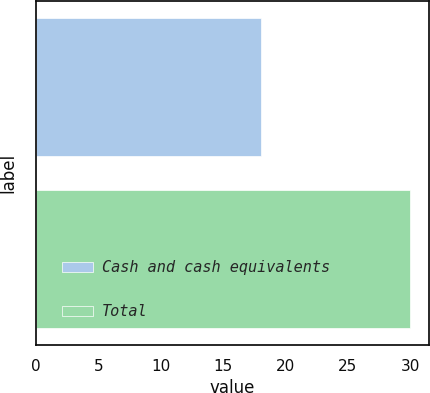Convert chart. <chart><loc_0><loc_0><loc_500><loc_500><bar_chart><fcel>Cash and cash equivalents<fcel>Total<nl><fcel>18<fcel>30<nl></chart> 